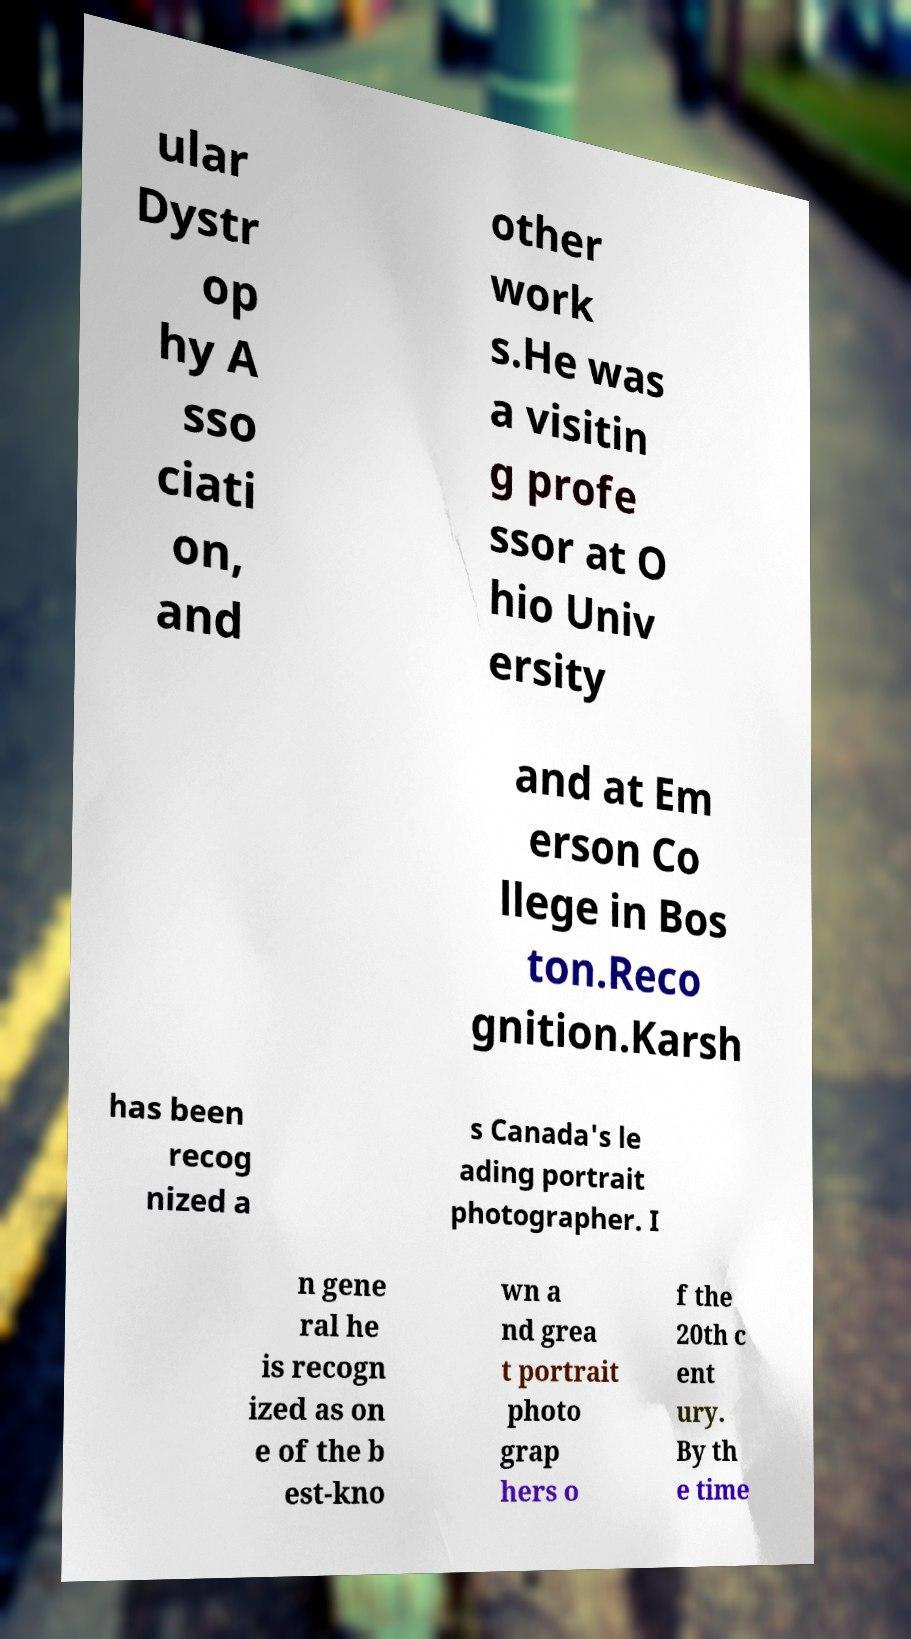Could you extract and type out the text from this image? ular Dystr op hy A sso ciati on, and other work s.He was a visitin g profe ssor at O hio Univ ersity and at Em erson Co llege in Bos ton.Reco gnition.Karsh has been recog nized a s Canada's le ading portrait photographer. I n gene ral he is recogn ized as on e of the b est-kno wn a nd grea t portrait photo grap hers o f the 20th c ent ury. By th e time 